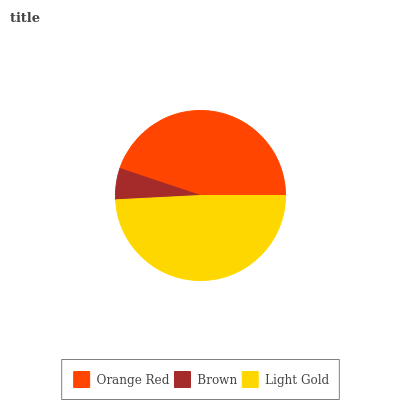Is Brown the minimum?
Answer yes or no. Yes. Is Light Gold the maximum?
Answer yes or no. Yes. Is Light Gold the minimum?
Answer yes or no. No. Is Brown the maximum?
Answer yes or no. No. Is Light Gold greater than Brown?
Answer yes or no. Yes. Is Brown less than Light Gold?
Answer yes or no. Yes. Is Brown greater than Light Gold?
Answer yes or no. No. Is Light Gold less than Brown?
Answer yes or no. No. Is Orange Red the high median?
Answer yes or no. Yes. Is Orange Red the low median?
Answer yes or no. Yes. Is Brown the high median?
Answer yes or no. No. Is Light Gold the low median?
Answer yes or no. No. 